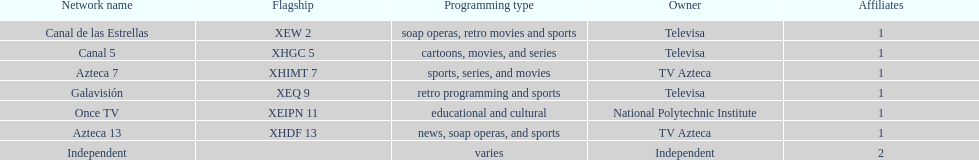Name a station that shows sports but is not televisa. Azteca 7. 